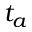Convert formula to latex. <formula><loc_0><loc_0><loc_500><loc_500>t _ { a }</formula> 